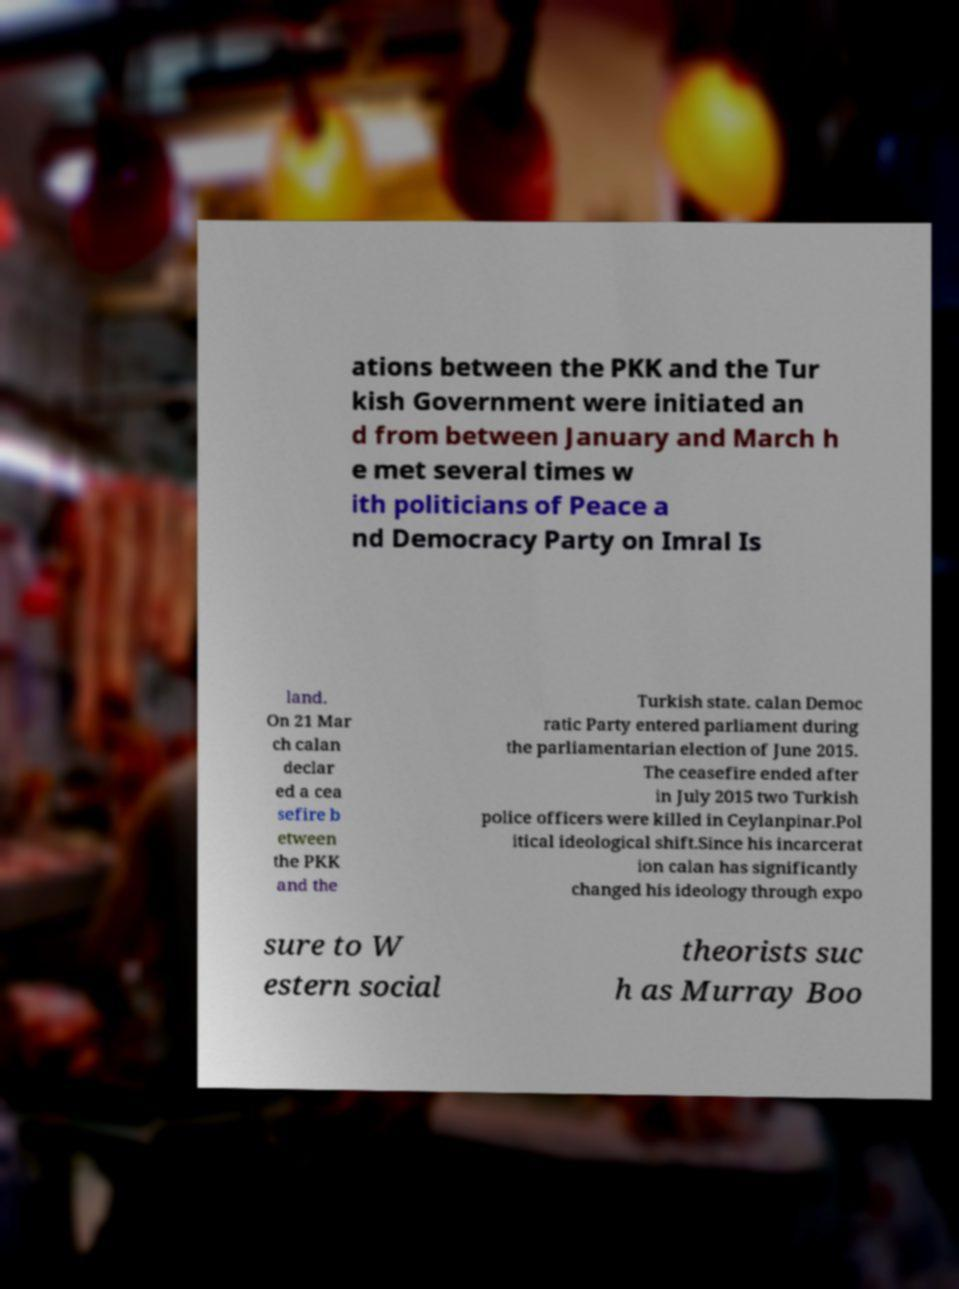What messages or text are displayed in this image? I need them in a readable, typed format. ations between the PKK and the Tur kish Government were initiated an d from between January and March h e met several times w ith politicians of Peace a nd Democracy Party on Imral Is land. On 21 Mar ch calan declar ed a cea sefire b etween the PKK and the Turkish state. calan Democ ratic Party entered parliament during the parliamentarian election of June 2015. The ceasefire ended after in July 2015 two Turkish police officers were killed in Ceylanpinar.Pol itical ideological shift.Since his incarcerat ion calan has significantly changed his ideology through expo sure to W estern social theorists suc h as Murray Boo 